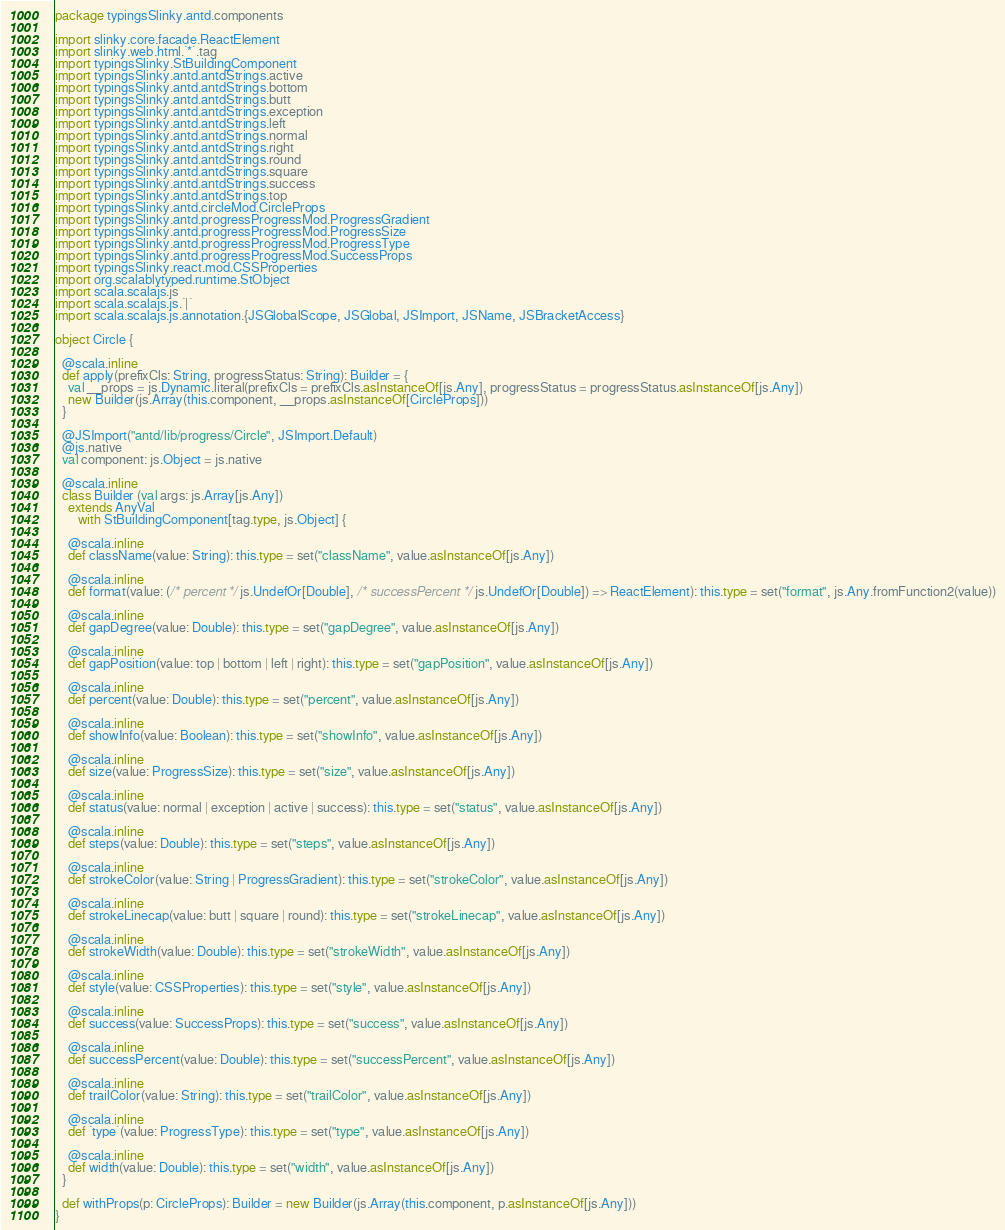<code> <loc_0><loc_0><loc_500><loc_500><_Scala_>package typingsSlinky.antd.components

import slinky.core.facade.ReactElement
import slinky.web.html.`*`.tag
import typingsSlinky.StBuildingComponent
import typingsSlinky.antd.antdStrings.active
import typingsSlinky.antd.antdStrings.bottom
import typingsSlinky.antd.antdStrings.butt
import typingsSlinky.antd.antdStrings.exception
import typingsSlinky.antd.antdStrings.left
import typingsSlinky.antd.antdStrings.normal
import typingsSlinky.antd.antdStrings.right
import typingsSlinky.antd.antdStrings.round
import typingsSlinky.antd.antdStrings.square
import typingsSlinky.antd.antdStrings.success
import typingsSlinky.antd.antdStrings.top
import typingsSlinky.antd.circleMod.CircleProps
import typingsSlinky.antd.progressProgressMod.ProgressGradient
import typingsSlinky.antd.progressProgressMod.ProgressSize
import typingsSlinky.antd.progressProgressMod.ProgressType
import typingsSlinky.antd.progressProgressMod.SuccessProps
import typingsSlinky.react.mod.CSSProperties
import org.scalablytyped.runtime.StObject
import scala.scalajs.js
import scala.scalajs.js.`|`
import scala.scalajs.js.annotation.{JSGlobalScope, JSGlobal, JSImport, JSName, JSBracketAccess}

object Circle {
  
  @scala.inline
  def apply(prefixCls: String, progressStatus: String): Builder = {
    val __props = js.Dynamic.literal(prefixCls = prefixCls.asInstanceOf[js.Any], progressStatus = progressStatus.asInstanceOf[js.Any])
    new Builder(js.Array(this.component, __props.asInstanceOf[CircleProps]))
  }
  
  @JSImport("antd/lib/progress/Circle", JSImport.Default)
  @js.native
  val component: js.Object = js.native
  
  @scala.inline
  class Builder (val args: js.Array[js.Any])
    extends AnyVal
       with StBuildingComponent[tag.type, js.Object] {
    
    @scala.inline
    def className(value: String): this.type = set("className", value.asInstanceOf[js.Any])
    
    @scala.inline
    def format(value: (/* percent */ js.UndefOr[Double], /* successPercent */ js.UndefOr[Double]) => ReactElement): this.type = set("format", js.Any.fromFunction2(value))
    
    @scala.inline
    def gapDegree(value: Double): this.type = set("gapDegree", value.asInstanceOf[js.Any])
    
    @scala.inline
    def gapPosition(value: top | bottom | left | right): this.type = set("gapPosition", value.asInstanceOf[js.Any])
    
    @scala.inline
    def percent(value: Double): this.type = set("percent", value.asInstanceOf[js.Any])
    
    @scala.inline
    def showInfo(value: Boolean): this.type = set("showInfo", value.asInstanceOf[js.Any])
    
    @scala.inline
    def size(value: ProgressSize): this.type = set("size", value.asInstanceOf[js.Any])
    
    @scala.inline
    def status(value: normal | exception | active | success): this.type = set("status", value.asInstanceOf[js.Any])
    
    @scala.inline
    def steps(value: Double): this.type = set("steps", value.asInstanceOf[js.Any])
    
    @scala.inline
    def strokeColor(value: String | ProgressGradient): this.type = set("strokeColor", value.asInstanceOf[js.Any])
    
    @scala.inline
    def strokeLinecap(value: butt | square | round): this.type = set("strokeLinecap", value.asInstanceOf[js.Any])
    
    @scala.inline
    def strokeWidth(value: Double): this.type = set("strokeWidth", value.asInstanceOf[js.Any])
    
    @scala.inline
    def style(value: CSSProperties): this.type = set("style", value.asInstanceOf[js.Any])
    
    @scala.inline
    def success(value: SuccessProps): this.type = set("success", value.asInstanceOf[js.Any])
    
    @scala.inline
    def successPercent(value: Double): this.type = set("successPercent", value.asInstanceOf[js.Any])
    
    @scala.inline
    def trailColor(value: String): this.type = set("trailColor", value.asInstanceOf[js.Any])
    
    @scala.inline
    def `type`(value: ProgressType): this.type = set("type", value.asInstanceOf[js.Any])
    
    @scala.inline
    def width(value: Double): this.type = set("width", value.asInstanceOf[js.Any])
  }
  
  def withProps(p: CircleProps): Builder = new Builder(js.Array(this.component, p.asInstanceOf[js.Any]))
}
</code> 